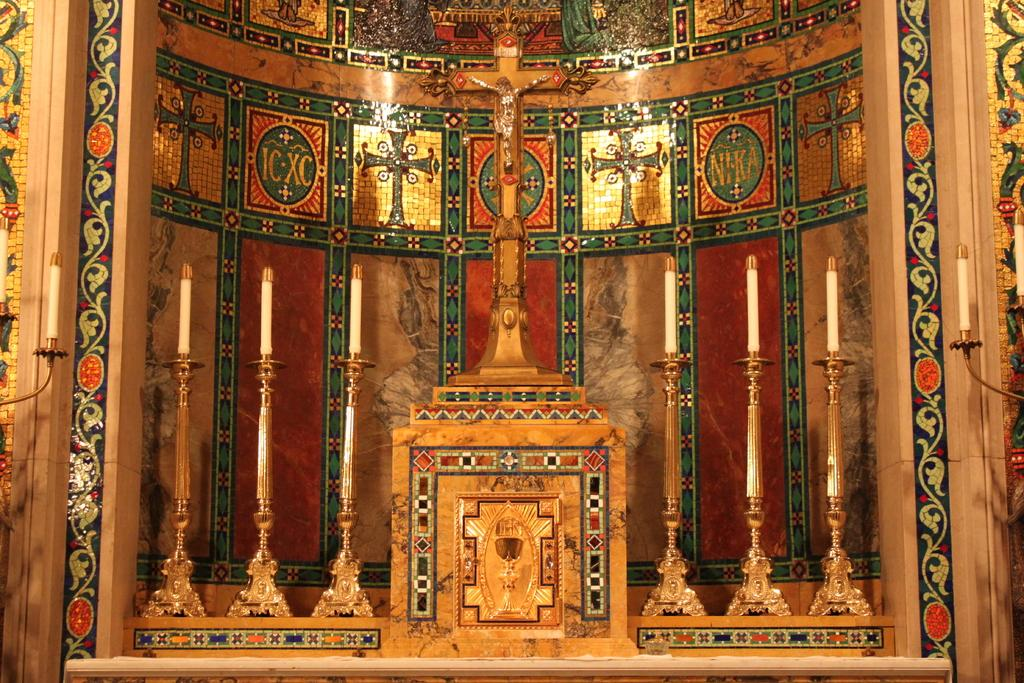What religious symbols are present in the image? There are Christianity symbols in the image. What is the main subject of the image? There is a statue of Jesus in the middle of the image. What objects are used to hold candles in the image? There are candle holders in the image. Are there any lit candles in the image? Yes, there are candles in the image. What type of smile can be seen on the statue's face in the image? The statue of Jesus in the image does not have a face that can display a smile. What emotion does the statue of Jesus express in the image? The statue of Jesus in the image is not expressing any emotion, as it is a static representation. 